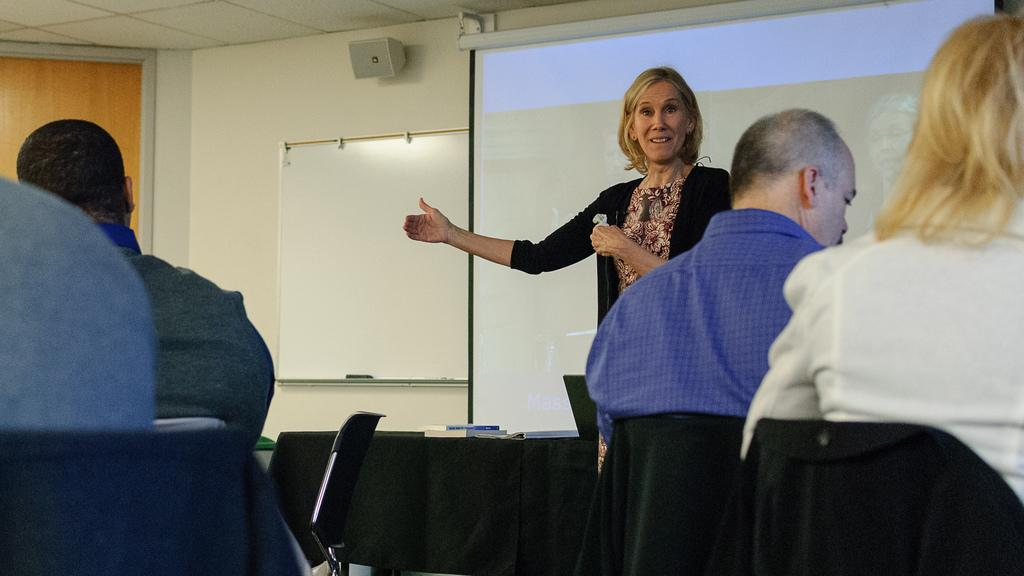What is the woman in the image doing? The woman is standing in the image. What are the other people in the image doing? There is a group of people sitting on chairs in the image. What can be seen on the wall in the image? There is a whiteboard on the wall in the image. What is the purpose of the screen in the image? The purpose of the screen in the image is not specified, but it could be used for presentations or displaying information. What type of finger food is being served on the tray in the image? There is no tray or finger food present in the image. 